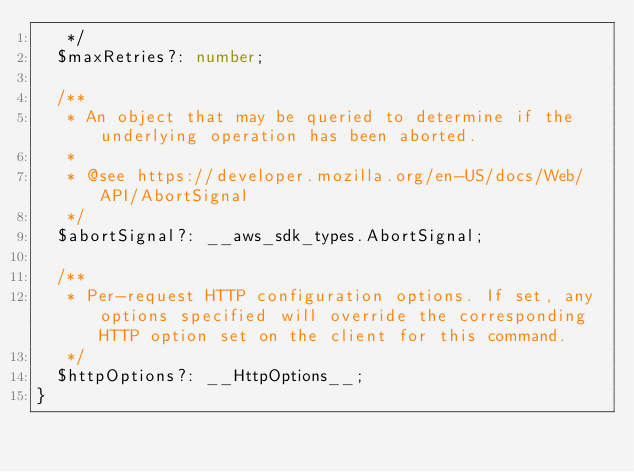Convert code to text. <code><loc_0><loc_0><loc_500><loc_500><_TypeScript_>   */
  $maxRetries?: number;

  /**
   * An object that may be queried to determine if the underlying operation has been aborted.
   *
   * @see https://developer.mozilla.org/en-US/docs/Web/API/AbortSignal
   */
  $abortSignal?: __aws_sdk_types.AbortSignal;

  /**
   * Per-request HTTP configuration options. If set, any options specified will override the corresponding HTTP option set on the client for this command.
   */
  $httpOptions?: __HttpOptions__;
}
</code> 